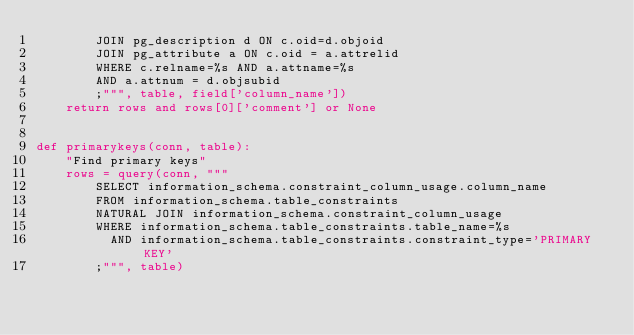Convert code to text. <code><loc_0><loc_0><loc_500><loc_500><_Python_>        JOIN pg_description d ON c.oid=d.objoid
        JOIN pg_attribute a ON c.oid = a.attrelid
        WHERE c.relname=%s AND a.attname=%s
        AND a.attnum = d.objsubid
        ;""", table, field['column_name'])
    return rows and rows[0]['comment'] or None


def primarykeys(conn, table):
    "Find primary keys"
    rows = query(conn, """
        SELECT information_schema.constraint_column_usage.column_name
        FROM information_schema.table_constraints
        NATURAL JOIN information_schema.constraint_column_usage
        WHERE information_schema.table_constraints.table_name=%s
          AND information_schema.table_constraints.constraint_type='PRIMARY KEY'
        ;""", table)</code> 